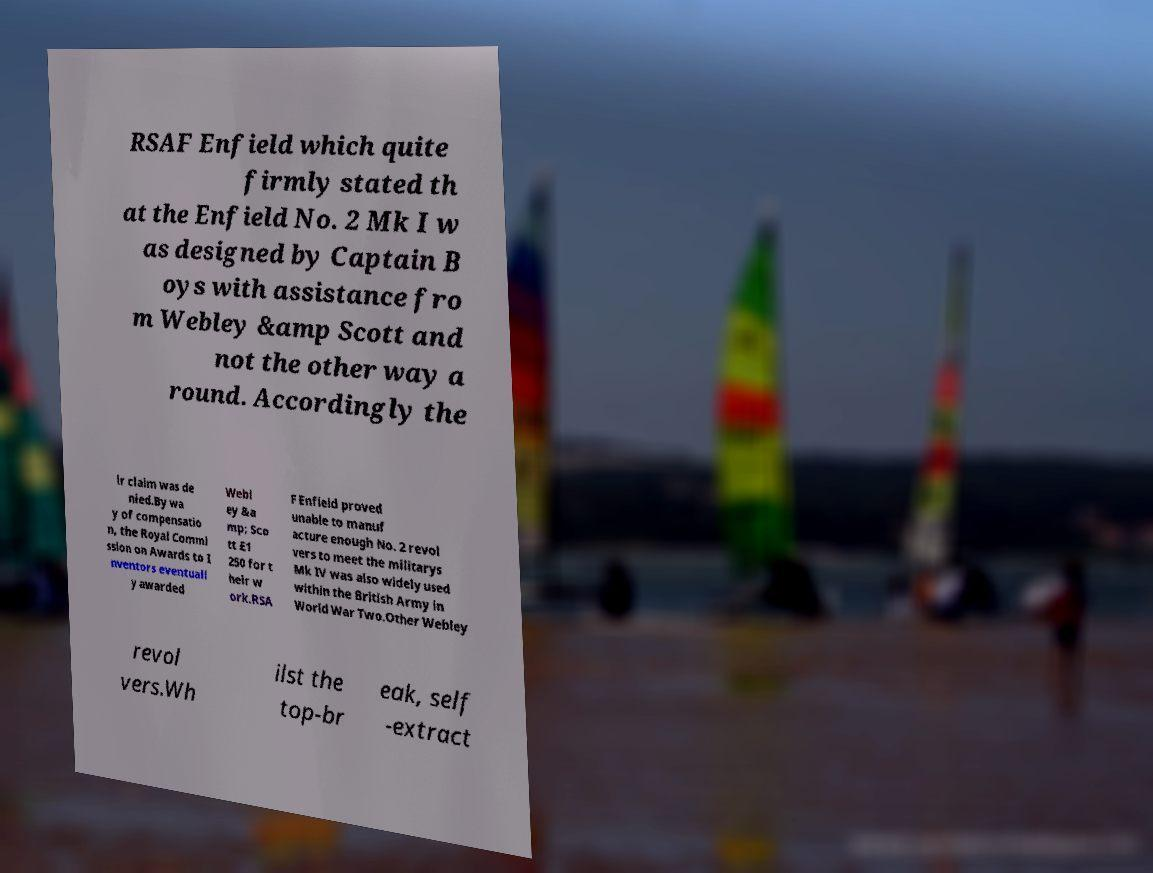Could you assist in decoding the text presented in this image and type it out clearly? RSAF Enfield which quite firmly stated th at the Enfield No. 2 Mk I w as designed by Captain B oys with assistance fro m Webley &amp Scott and not the other way a round. Accordingly the ir claim was de nied.By wa y of compensatio n, the Royal Commi ssion on Awards to I nventors eventuall y awarded Webl ey &a mp; Sco tt £1 250 for t heir w ork.RSA F Enfield proved unable to manuf acture enough No. 2 revol vers to meet the militarys Mk IV was also widely used within the British Army in World War Two.Other Webley revol vers.Wh ilst the top-br eak, self -extract 